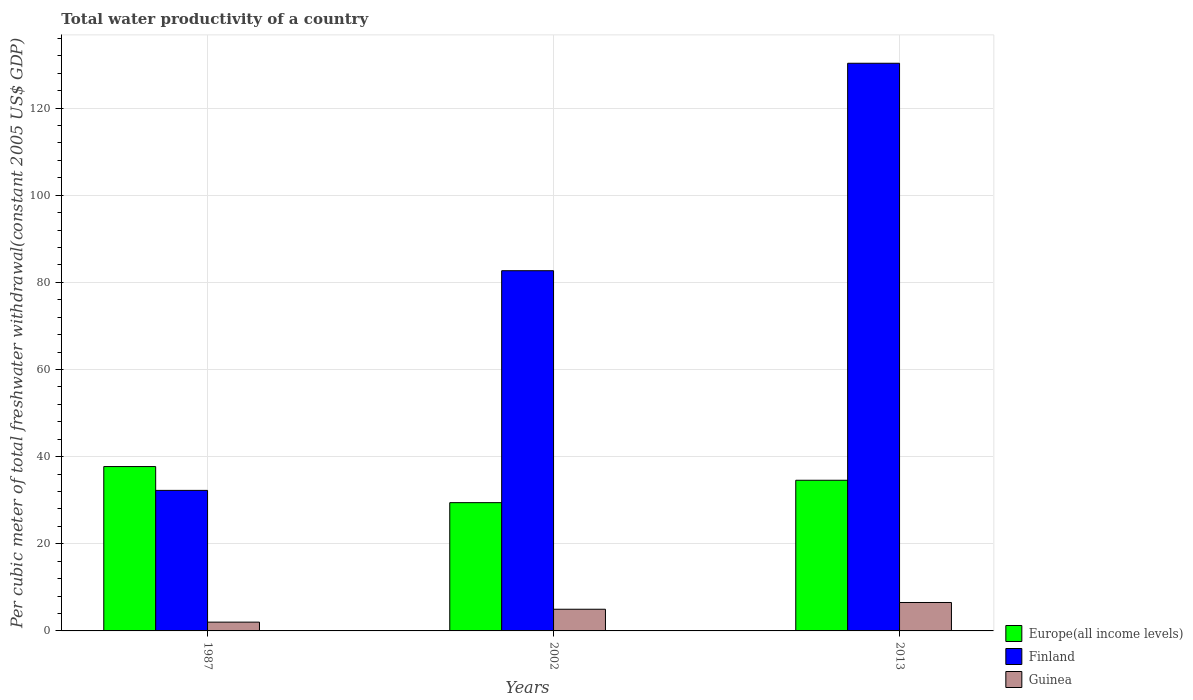How many groups of bars are there?
Provide a succinct answer. 3. Are the number of bars per tick equal to the number of legend labels?
Your answer should be very brief. Yes. Are the number of bars on each tick of the X-axis equal?
Provide a short and direct response. Yes. How many bars are there on the 2nd tick from the right?
Provide a succinct answer. 3. In how many cases, is the number of bars for a given year not equal to the number of legend labels?
Offer a very short reply. 0. What is the total water productivity in Guinea in 2013?
Your answer should be very brief. 6.53. Across all years, what is the maximum total water productivity in Guinea?
Provide a short and direct response. 6.53. Across all years, what is the minimum total water productivity in Guinea?
Ensure brevity in your answer.  2.02. In which year was the total water productivity in Europe(all income levels) maximum?
Make the answer very short. 1987. What is the total total water productivity in Finland in the graph?
Make the answer very short. 245.19. What is the difference between the total water productivity in Guinea in 2002 and that in 2013?
Provide a short and direct response. -1.55. What is the difference between the total water productivity in Guinea in 1987 and the total water productivity in Finland in 2002?
Provide a succinct answer. -80.65. What is the average total water productivity in Finland per year?
Make the answer very short. 81.73. In the year 1987, what is the difference between the total water productivity in Europe(all income levels) and total water productivity in Finland?
Keep it short and to the point. 5.47. What is the ratio of the total water productivity in Finland in 2002 to that in 2013?
Provide a succinct answer. 0.63. Is the total water productivity in Guinea in 2002 less than that in 2013?
Provide a succinct answer. Yes. What is the difference between the highest and the second highest total water productivity in Guinea?
Your response must be concise. 1.55. What is the difference between the highest and the lowest total water productivity in Finland?
Your answer should be very brief. 98.02. What does the 3rd bar from the right in 2013 represents?
Your answer should be compact. Europe(all income levels). Is it the case that in every year, the sum of the total water productivity in Guinea and total water productivity in Europe(all income levels) is greater than the total water productivity in Finland?
Offer a terse response. No. How many bars are there?
Give a very brief answer. 9. Are the values on the major ticks of Y-axis written in scientific E-notation?
Provide a short and direct response. No. What is the title of the graph?
Offer a terse response. Total water productivity of a country. What is the label or title of the X-axis?
Keep it short and to the point. Years. What is the label or title of the Y-axis?
Your answer should be compact. Per cubic meter of total freshwater withdrawal(constant 2005 US$ GDP). What is the Per cubic meter of total freshwater withdrawal(constant 2005 US$ GDP) of Europe(all income levels) in 1987?
Give a very brief answer. 37.72. What is the Per cubic meter of total freshwater withdrawal(constant 2005 US$ GDP) of Finland in 1987?
Your answer should be compact. 32.25. What is the Per cubic meter of total freshwater withdrawal(constant 2005 US$ GDP) in Guinea in 1987?
Provide a succinct answer. 2.02. What is the Per cubic meter of total freshwater withdrawal(constant 2005 US$ GDP) in Europe(all income levels) in 2002?
Your answer should be compact. 29.44. What is the Per cubic meter of total freshwater withdrawal(constant 2005 US$ GDP) in Finland in 2002?
Your answer should be compact. 82.67. What is the Per cubic meter of total freshwater withdrawal(constant 2005 US$ GDP) of Guinea in 2002?
Offer a terse response. 4.97. What is the Per cubic meter of total freshwater withdrawal(constant 2005 US$ GDP) of Europe(all income levels) in 2013?
Make the answer very short. 34.58. What is the Per cubic meter of total freshwater withdrawal(constant 2005 US$ GDP) in Finland in 2013?
Make the answer very short. 130.27. What is the Per cubic meter of total freshwater withdrawal(constant 2005 US$ GDP) of Guinea in 2013?
Provide a succinct answer. 6.53. Across all years, what is the maximum Per cubic meter of total freshwater withdrawal(constant 2005 US$ GDP) in Europe(all income levels)?
Your answer should be compact. 37.72. Across all years, what is the maximum Per cubic meter of total freshwater withdrawal(constant 2005 US$ GDP) in Finland?
Your answer should be compact. 130.27. Across all years, what is the maximum Per cubic meter of total freshwater withdrawal(constant 2005 US$ GDP) of Guinea?
Keep it short and to the point. 6.53. Across all years, what is the minimum Per cubic meter of total freshwater withdrawal(constant 2005 US$ GDP) in Europe(all income levels)?
Your answer should be very brief. 29.44. Across all years, what is the minimum Per cubic meter of total freshwater withdrawal(constant 2005 US$ GDP) of Finland?
Your response must be concise. 32.25. Across all years, what is the minimum Per cubic meter of total freshwater withdrawal(constant 2005 US$ GDP) in Guinea?
Give a very brief answer. 2.02. What is the total Per cubic meter of total freshwater withdrawal(constant 2005 US$ GDP) of Europe(all income levels) in the graph?
Your answer should be compact. 101.73. What is the total Per cubic meter of total freshwater withdrawal(constant 2005 US$ GDP) of Finland in the graph?
Make the answer very short. 245.19. What is the total Per cubic meter of total freshwater withdrawal(constant 2005 US$ GDP) in Guinea in the graph?
Keep it short and to the point. 13.52. What is the difference between the Per cubic meter of total freshwater withdrawal(constant 2005 US$ GDP) in Europe(all income levels) in 1987 and that in 2002?
Ensure brevity in your answer.  8.28. What is the difference between the Per cubic meter of total freshwater withdrawal(constant 2005 US$ GDP) of Finland in 1987 and that in 2002?
Offer a very short reply. -50.41. What is the difference between the Per cubic meter of total freshwater withdrawal(constant 2005 US$ GDP) of Guinea in 1987 and that in 2002?
Offer a terse response. -2.96. What is the difference between the Per cubic meter of total freshwater withdrawal(constant 2005 US$ GDP) of Europe(all income levels) in 1987 and that in 2013?
Offer a very short reply. 3.14. What is the difference between the Per cubic meter of total freshwater withdrawal(constant 2005 US$ GDP) in Finland in 1987 and that in 2013?
Offer a very short reply. -98.02. What is the difference between the Per cubic meter of total freshwater withdrawal(constant 2005 US$ GDP) of Guinea in 1987 and that in 2013?
Your response must be concise. -4.51. What is the difference between the Per cubic meter of total freshwater withdrawal(constant 2005 US$ GDP) of Europe(all income levels) in 2002 and that in 2013?
Provide a succinct answer. -5.14. What is the difference between the Per cubic meter of total freshwater withdrawal(constant 2005 US$ GDP) of Finland in 2002 and that in 2013?
Your answer should be very brief. -47.61. What is the difference between the Per cubic meter of total freshwater withdrawal(constant 2005 US$ GDP) in Guinea in 2002 and that in 2013?
Provide a short and direct response. -1.55. What is the difference between the Per cubic meter of total freshwater withdrawal(constant 2005 US$ GDP) in Europe(all income levels) in 1987 and the Per cubic meter of total freshwater withdrawal(constant 2005 US$ GDP) in Finland in 2002?
Your response must be concise. -44.95. What is the difference between the Per cubic meter of total freshwater withdrawal(constant 2005 US$ GDP) of Europe(all income levels) in 1987 and the Per cubic meter of total freshwater withdrawal(constant 2005 US$ GDP) of Guinea in 2002?
Ensure brevity in your answer.  32.75. What is the difference between the Per cubic meter of total freshwater withdrawal(constant 2005 US$ GDP) in Finland in 1987 and the Per cubic meter of total freshwater withdrawal(constant 2005 US$ GDP) in Guinea in 2002?
Offer a very short reply. 27.28. What is the difference between the Per cubic meter of total freshwater withdrawal(constant 2005 US$ GDP) in Europe(all income levels) in 1987 and the Per cubic meter of total freshwater withdrawal(constant 2005 US$ GDP) in Finland in 2013?
Your answer should be very brief. -92.55. What is the difference between the Per cubic meter of total freshwater withdrawal(constant 2005 US$ GDP) in Europe(all income levels) in 1987 and the Per cubic meter of total freshwater withdrawal(constant 2005 US$ GDP) in Guinea in 2013?
Offer a terse response. 31.19. What is the difference between the Per cubic meter of total freshwater withdrawal(constant 2005 US$ GDP) in Finland in 1987 and the Per cubic meter of total freshwater withdrawal(constant 2005 US$ GDP) in Guinea in 2013?
Keep it short and to the point. 25.73. What is the difference between the Per cubic meter of total freshwater withdrawal(constant 2005 US$ GDP) of Europe(all income levels) in 2002 and the Per cubic meter of total freshwater withdrawal(constant 2005 US$ GDP) of Finland in 2013?
Your answer should be compact. -100.83. What is the difference between the Per cubic meter of total freshwater withdrawal(constant 2005 US$ GDP) in Europe(all income levels) in 2002 and the Per cubic meter of total freshwater withdrawal(constant 2005 US$ GDP) in Guinea in 2013?
Provide a succinct answer. 22.91. What is the difference between the Per cubic meter of total freshwater withdrawal(constant 2005 US$ GDP) of Finland in 2002 and the Per cubic meter of total freshwater withdrawal(constant 2005 US$ GDP) of Guinea in 2013?
Your answer should be compact. 76.14. What is the average Per cubic meter of total freshwater withdrawal(constant 2005 US$ GDP) of Europe(all income levels) per year?
Your answer should be very brief. 33.91. What is the average Per cubic meter of total freshwater withdrawal(constant 2005 US$ GDP) in Finland per year?
Your answer should be very brief. 81.73. What is the average Per cubic meter of total freshwater withdrawal(constant 2005 US$ GDP) in Guinea per year?
Offer a terse response. 4.5. In the year 1987, what is the difference between the Per cubic meter of total freshwater withdrawal(constant 2005 US$ GDP) of Europe(all income levels) and Per cubic meter of total freshwater withdrawal(constant 2005 US$ GDP) of Finland?
Your answer should be very brief. 5.47. In the year 1987, what is the difference between the Per cubic meter of total freshwater withdrawal(constant 2005 US$ GDP) of Europe(all income levels) and Per cubic meter of total freshwater withdrawal(constant 2005 US$ GDP) of Guinea?
Make the answer very short. 35.7. In the year 1987, what is the difference between the Per cubic meter of total freshwater withdrawal(constant 2005 US$ GDP) of Finland and Per cubic meter of total freshwater withdrawal(constant 2005 US$ GDP) of Guinea?
Provide a short and direct response. 30.24. In the year 2002, what is the difference between the Per cubic meter of total freshwater withdrawal(constant 2005 US$ GDP) of Europe(all income levels) and Per cubic meter of total freshwater withdrawal(constant 2005 US$ GDP) of Finland?
Provide a short and direct response. -53.23. In the year 2002, what is the difference between the Per cubic meter of total freshwater withdrawal(constant 2005 US$ GDP) in Europe(all income levels) and Per cubic meter of total freshwater withdrawal(constant 2005 US$ GDP) in Guinea?
Your response must be concise. 24.46. In the year 2002, what is the difference between the Per cubic meter of total freshwater withdrawal(constant 2005 US$ GDP) of Finland and Per cubic meter of total freshwater withdrawal(constant 2005 US$ GDP) of Guinea?
Ensure brevity in your answer.  77.69. In the year 2013, what is the difference between the Per cubic meter of total freshwater withdrawal(constant 2005 US$ GDP) in Europe(all income levels) and Per cubic meter of total freshwater withdrawal(constant 2005 US$ GDP) in Finland?
Your answer should be very brief. -95.7. In the year 2013, what is the difference between the Per cubic meter of total freshwater withdrawal(constant 2005 US$ GDP) of Europe(all income levels) and Per cubic meter of total freshwater withdrawal(constant 2005 US$ GDP) of Guinea?
Give a very brief answer. 28.05. In the year 2013, what is the difference between the Per cubic meter of total freshwater withdrawal(constant 2005 US$ GDP) of Finland and Per cubic meter of total freshwater withdrawal(constant 2005 US$ GDP) of Guinea?
Offer a terse response. 123.75. What is the ratio of the Per cubic meter of total freshwater withdrawal(constant 2005 US$ GDP) in Europe(all income levels) in 1987 to that in 2002?
Your response must be concise. 1.28. What is the ratio of the Per cubic meter of total freshwater withdrawal(constant 2005 US$ GDP) in Finland in 1987 to that in 2002?
Ensure brevity in your answer.  0.39. What is the ratio of the Per cubic meter of total freshwater withdrawal(constant 2005 US$ GDP) in Guinea in 1987 to that in 2002?
Provide a succinct answer. 0.41. What is the ratio of the Per cubic meter of total freshwater withdrawal(constant 2005 US$ GDP) in Finland in 1987 to that in 2013?
Give a very brief answer. 0.25. What is the ratio of the Per cubic meter of total freshwater withdrawal(constant 2005 US$ GDP) of Guinea in 1987 to that in 2013?
Provide a short and direct response. 0.31. What is the ratio of the Per cubic meter of total freshwater withdrawal(constant 2005 US$ GDP) of Europe(all income levels) in 2002 to that in 2013?
Offer a terse response. 0.85. What is the ratio of the Per cubic meter of total freshwater withdrawal(constant 2005 US$ GDP) in Finland in 2002 to that in 2013?
Your answer should be compact. 0.63. What is the ratio of the Per cubic meter of total freshwater withdrawal(constant 2005 US$ GDP) of Guinea in 2002 to that in 2013?
Your answer should be very brief. 0.76. What is the difference between the highest and the second highest Per cubic meter of total freshwater withdrawal(constant 2005 US$ GDP) in Europe(all income levels)?
Keep it short and to the point. 3.14. What is the difference between the highest and the second highest Per cubic meter of total freshwater withdrawal(constant 2005 US$ GDP) of Finland?
Ensure brevity in your answer.  47.61. What is the difference between the highest and the second highest Per cubic meter of total freshwater withdrawal(constant 2005 US$ GDP) in Guinea?
Your response must be concise. 1.55. What is the difference between the highest and the lowest Per cubic meter of total freshwater withdrawal(constant 2005 US$ GDP) in Europe(all income levels)?
Offer a very short reply. 8.28. What is the difference between the highest and the lowest Per cubic meter of total freshwater withdrawal(constant 2005 US$ GDP) in Finland?
Give a very brief answer. 98.02. What is the difference between the highest and the lowest Per cubic meter of total freshwater withdrawal(constant 2005 US$ GDP) of Guinea?
Give a very brief answer. 4.51. 